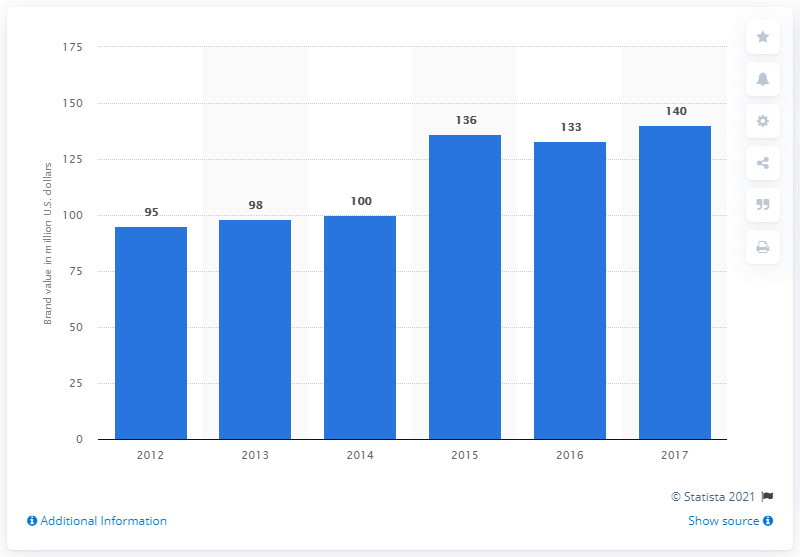Highlight a few significant elements in this photo. The brand value of the Daytona 500 in dollars in 2017 was estimated to be approximately $140 million. 